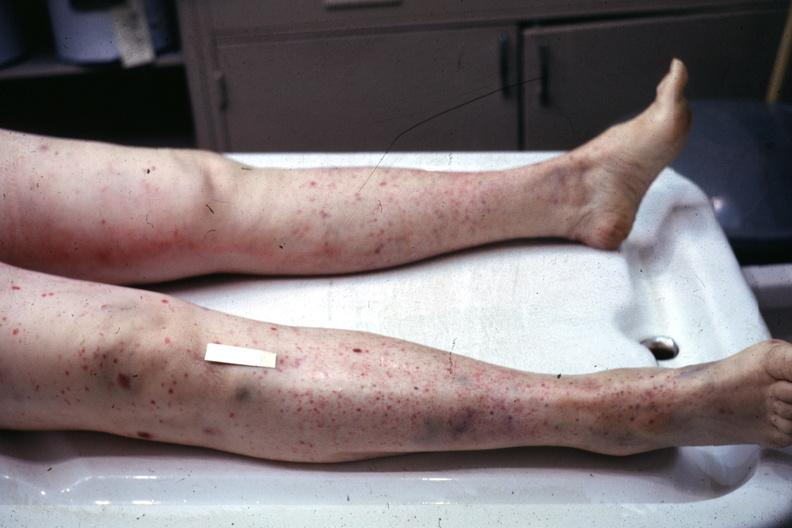what are present?
Answer the question using a single word or phrase. Extremities 